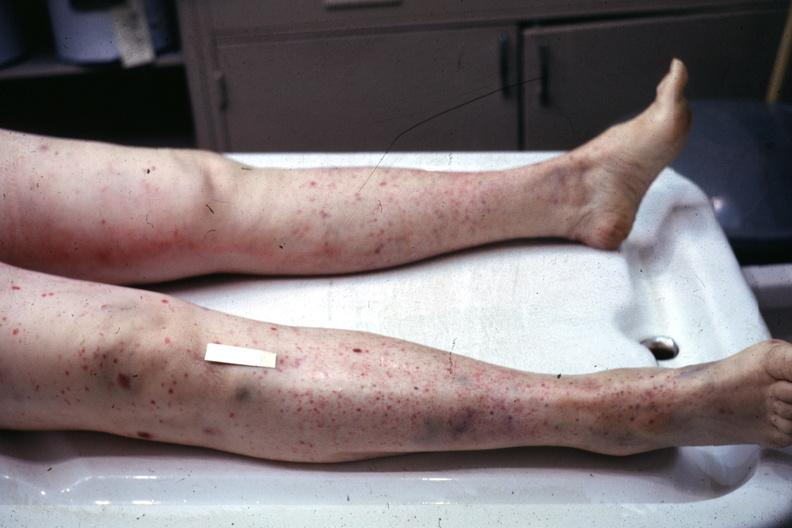what are present?
Answer the question using a single word or phrase. Extremities 